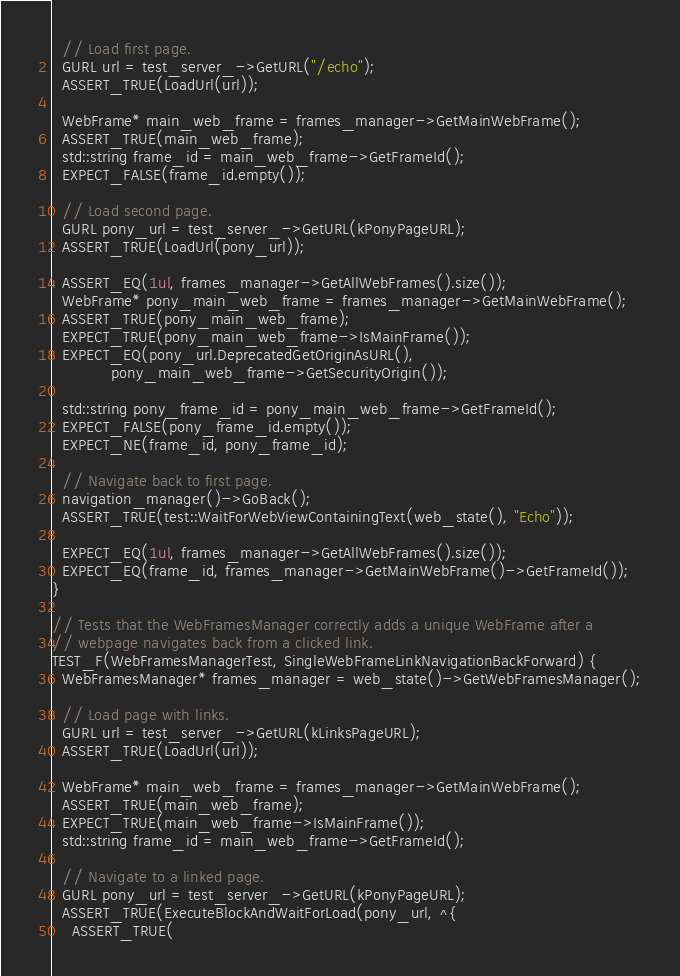Convert code to text. <code><loc_0><loc_0><loc_500><loc_500><_ObjectiveC_>  // Load first page.
  GURL url = test_server_->GetURL("/echo");
  ASSERT_TRUE(LoadUrl(url));

  WebFrame* main_web_frame = frames_manager->GetMainWebFrame();
  ASSERT_TRUE(main_web_frame);
  std::string frame_id = main_web_frame->GetFrameId();
  EXPECT_FALSE(frame_id.empty());

  // Load second page.
  GURL pony_url = test_server_->GetURL(kPonyPageURL);
  ASSERT_TRUE(LoadUrl(pony_url));

  ASSERT_EQ(1ul, frames_manager->GetAllWebFrames().size());
  WebFrame* pony_main_web_frame = frames_manager->GetMainWebFrame();
  ASSERT_TRUE(pony_main_web_frame);
  EXPECT_TRUE(pony_main_web_frame->IsMainFrame());
  EXPECT_EQ(pony_url.DeprecatedGetOriginAsURL(),
            pony_main_web_frame->GetSecurityOrigin());

  std::string pony_frame_id = pony_main_web_frame->GetFrameId();
  EXPECT_FALSE(pony_frame_id.empty());
  EXPECT_NE(frame_id, pony_frame_id);

  // Navigate back to first page.
  navigation_manager()->GoBack();
  ASSERT_TRUE(test::WaitForWebViewContainingText(web_state(), "Echo"));

  EXPECT_EQ(1ul, frames_manager->GetAllWebFrames().size());
  EXPECT_EQ(frame_id, frames_manager->GetMainWebFrame()->GetFrameId());
}

// Tests that the WebFramesManager correctly adds a unique WebFrame after a
// webpage navigates back from a clicked link.
TEST_F(WebFramesManagerTest, SingleWebFrameLinkNavigationBackForward) {
  WebFramesManager* frames_manager = web_state()->GetWebFramesManager();

  // Load page with links.
  GURL url = test_server_->GetURL(kLinksPageURL);
  ASSERT_TRUE(LoadUrl(url));

  WebFrame* main_web_frame = frames_manager->GetMainWebFrame();
  ASSERT_TRUE(main_web_frame);
  EXPECT_TRUE(main_web_frame->IsMainFrame());
  std::string frame_id = main_web_frame->GetFrameId();

  // Navigate to a linked page.
  GURL pony_url = test_server_->GetURL(kPonyPageURL);
  ASSERT_TRUE(ExecuteBlockAndWaitForLoad(pony_url, ^{
    ASSERT_TRUE(</code> 